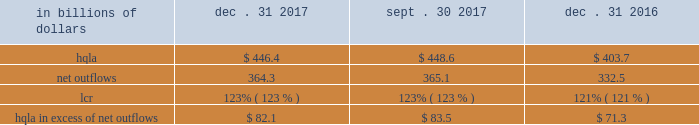Liquidity monitoring and measurement stress testing liquidity stress testing is performed for each of citi 2019s major entities , operating subsidiaries and/or countries .
Stress testing and scenario analyses are intended to quantify the potential impact of an adverse liquidity event on the balance sheet and liquidity position , and to identify viable funding alternatives that can be utilized .
These scenarios include assumptions about significant changes in key funding sources , market triggers ( such as credit ratings ) , potential uses of funding and geopolitical and macroeconomic conditions .
These conditions include expected and stressed market conditions as well as company-specific events .
Liquidity stress tests are conducted to ascertain potential mismatches between liquidity sources and uses over a variety of time horizons and over different stressed conditions .
Liquidity limits are set accordingly .
To monitor the liquidity of an entity , these stress tests and potential mismatches are calculated with varying frequencies , with several tests performed daily .
Given the range of potential stresses , citi maintains contingency funding plans on a consolidated basis and for individual entities .
These plans specify a wide range of readily available actions for a variety of adverse market conditions or idiosyncratic stresses .
Short-term liquidity measurement : liquidity coverage ratio ( lcr ) in addition to internal liquidity stress metrics that citi has developed for a 30-day stress scenario , citi also monitors its liquidity by reference to the lcr , as calculated pursuant to the u.s .
Lcr rules .
Generally , the lcr is designed to ensure that banks maintain an adequate level of hqla to meet liquidity needs under an acute 30-day stress scenario .
The lcr is calculated by dividing hqla by estimated net outflows over a stressed 30-day period , with the net outflows determined by applying prescribed outflow factors to various categories of liabilities , such as deposits , unsecured and secured wholesale borrowings , unused lending commitments and derivatives- related exposures , partially offset by inflows from assets maturing within 30 days .
Banks are required to calculate an add-on to address potential maturity mismatches between contractual cash outflows and inflows within the 30-day period in determining the total amount of net outflows .
The minimum lcr requirement is 100% ( 100 % ) , effective january 2017 .
Pursuant to the federal reserve board 2019s final rule regarding lcr disclosures , effective april 1 , 2017 , citi began to disclose lcr in the prescribed format .
The table below sets forth the components of citi 2019s lcr calculation and hqla in excess of net outflows for the periods indicated : in billions of dollars dec .
31 , sept .
30 , dec .
31 .
Note : amounts set forth in the table above are presented on an average basis .
As set forth in the table above , citi 2019s lcr increased year- over-year , as the increase in the hqla ( as discussed above ) more than offset an increase in modeled net outflows .
The increase in modeled net outflows was primarily driven by changes in assumptions , including changes in methodology to better align citi 2019s outflow assumptions with those embedded in its resolution planning .
Sequentially , citi 2019s lcr remained unchanged .
Long-term liquidity measurement : net stable funding ratio ( nsfr ) in 2016 , the federal reserve board , the fdic and the occ issued a proposed rule to implement the basel iii nsfr requirement .
The u.s.-proposed nsfr is largely consistent with the basel committee 2019s final nsfr rules .
In general , the nsfr assesses the availability of a bank 2019s stable funding against a required level .
A bank 2019s available stable funding would include portions of equity , deposits and long-term debt , while its required stable funding would be based on the liquidity characteristics of its assets , derivatives and commitments .
Prescribed factors would be required to be applied to the various categories of asset and liabilities classes .
The ratio of available stable funding to required stable funding would be required to be greater than 100% ( 100 % ) .
While citi believes that it is compliant with the proposed u.s .
Nsfr rules as of december 31 , 2017 , it will need to evaluate a final version of the rules , which are expected to be released during 2018 .
Citi expects that the nsfr final rules implementation period will be communicated along with the final version of the rules. .
What was the percentage increase of the hqla in excess of net outflows 2016 to 2017? 
Computations: ((82.1 - 71.3) / 71.3)
Answer: 0.15147. 